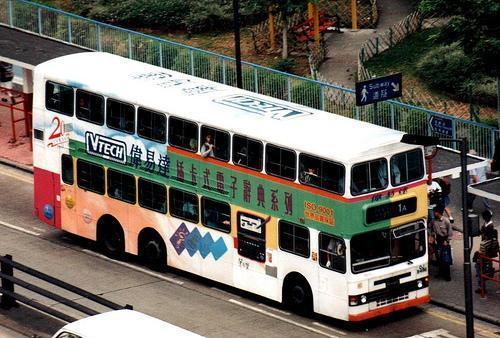How many buses are seen?
Give a very brief answer. 1. 